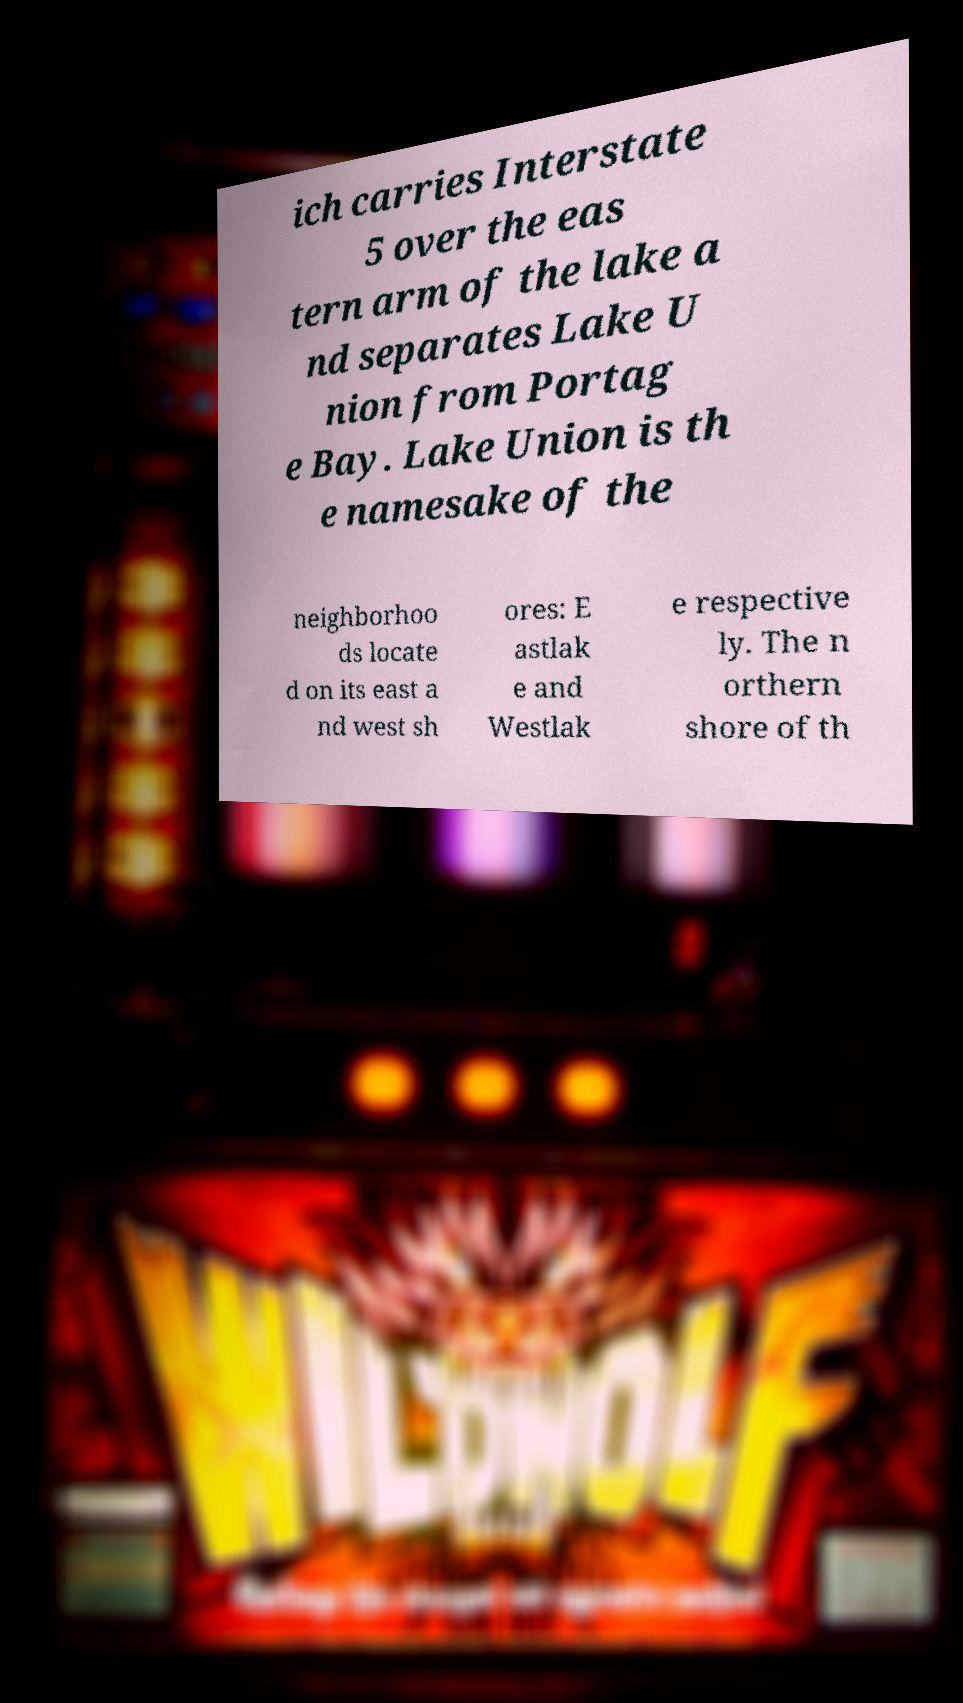Could you extract and type out the text from this image? ich carries Interstate 5 over the eas tern arm of the lake a nd separates Lake U nion from Portag e Bay. Lake Union is th e namesake of the neighborhoo ds locate d on its east a nd west sh ores: E astlak e and Westlak e respective ly. The n orthern shore of th 